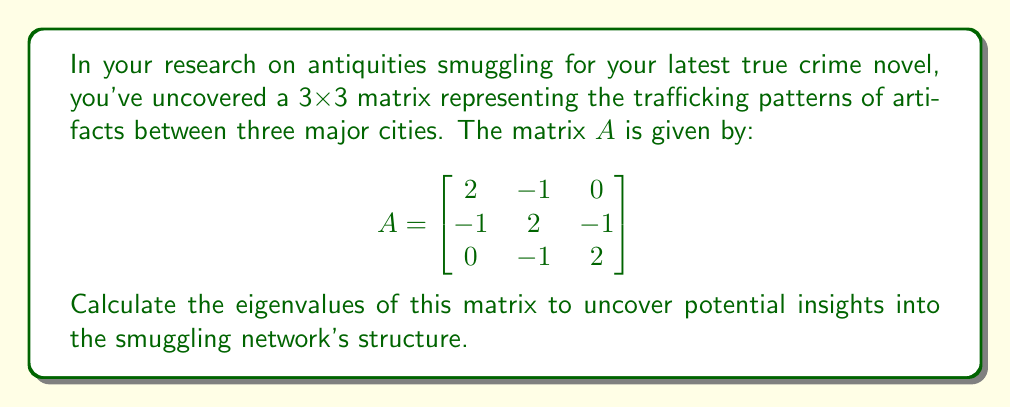Can you answer this question? To find the eigenvalues of matrix A, we need to solve the characteristic equation:

1) First, we set up the equation $det(A - \lambda I) = 0$, where $\lambda$ represents the eigenvalues and I is the 3x3 identity matrix:

   $$det\begin{pmatrix}
   2-\lambda & -1 & 0 \\
   -1 & 2-\lambda & -1 \\
   0 & -1 & 2-\lambda
   \end{pmatrix} = 0$$

2) Expand the determinant:
   $$(2-\lambda)[(2-\lambda)(2-\lambda) - 1] - (-1)[(-1)(2-\lambda) - 0] = 0$$

3) Simplify:
   $$(2-\lambda)[(4-4\lambda+\lambda^2) - 1] + (2-\lambda) = 0$$
   $$(2-\lambda)(3-4\lambda+\lambda^2) + (2-\lambda) = 0$$

4) Expand:
   $$6-8\lambda+2\lambda^2-3\lambda+4\lambda^2-\lambda^3+2-\lambda = 0$$

5) Collect like terms:
   $$-\lambda^3 + 6\lambda^2 - 11\lambda + 8 = 0$$

6) This is a cubic equation. We can factor out $(\lambda - 2)$:
   $$(\lambda - 2)(-\lambda^2 + 4\lambda - 4) = 0$$

7) The quadratic part can be further factored:
   $$(\lambda - 2)(\lambda - 2)(\lambda - 2) = 0$$

Therefore, the eigenvalue is $\lambda = 2$ with algebraic multiplicity 3.
Answer: $\lambda = 2$ (with multiplicity 3) 